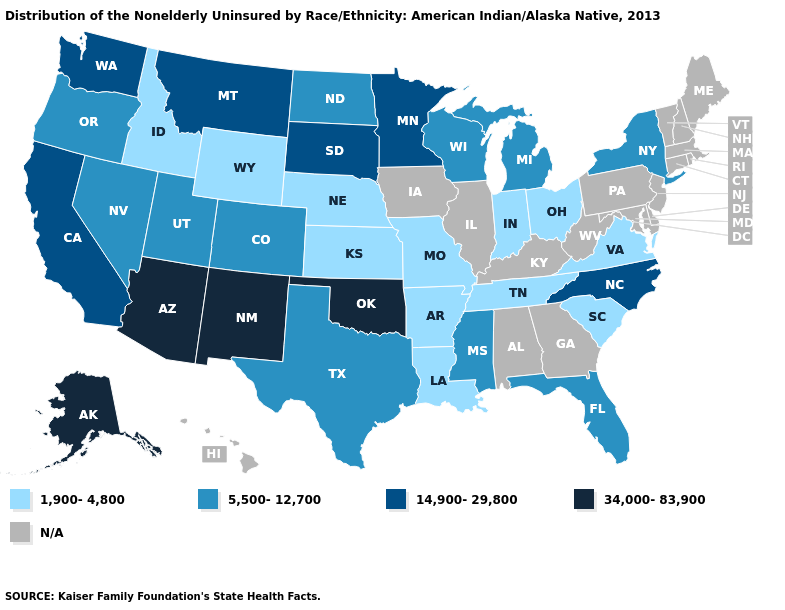What is the lowest value in the USA?
Short answer required. 1,900-4,800. Is the legend a continuous bar?
Answer briefly. No. Does the first symbol in the legend represent the smallest category?
Short answer required. Yes. Name the states that have a value in the range 1,900-4,800?
Concise answer only. Arkansas, Idaho, Indiana, Kansas, Louisiana, Missouri, Nebraska, Ohio, South Carolina, Tennessee, Virginia, Wyoming. Name the states that have a value in the range N/A?
Give a very brief answer. Alabama, Connecticut, Delaware, Georgia, Hawaii, Illinois, Iowa, Kentucky, Maine, Maryland, Massachusetts, New Hampshire, New Jersey, Pennsylvania, Rhode Island, Vermont, West Virginia. What is the value of Hawaii?
Give a very brief answer. N/A. Does Tennessee have the lowest value in the USA?
Quick response, please. Yes. What is the value of New Jersey?
Concise answer only. N/A. What is the value of Maryland?
Quick response, please. N/A. Does the first symbol in the legend represent the smallest category?
Answer briefly. Yes. What is the lowest value in the MidWest?
Quick response, please. 1,900-4,800. Name the states that have a value in the range 14,900-29,800?
Write a very short answer. California, Minnesota, Montana, North Carolina, South Dakota, Washington. Among the states that border Kansas , which have the lowest value?
Short answer required. Missouri, Nebraska. How many symbols are there in the legend?
Concise answer only. 5. How many symbols are there in the legend?
Keep it brief. 5. 